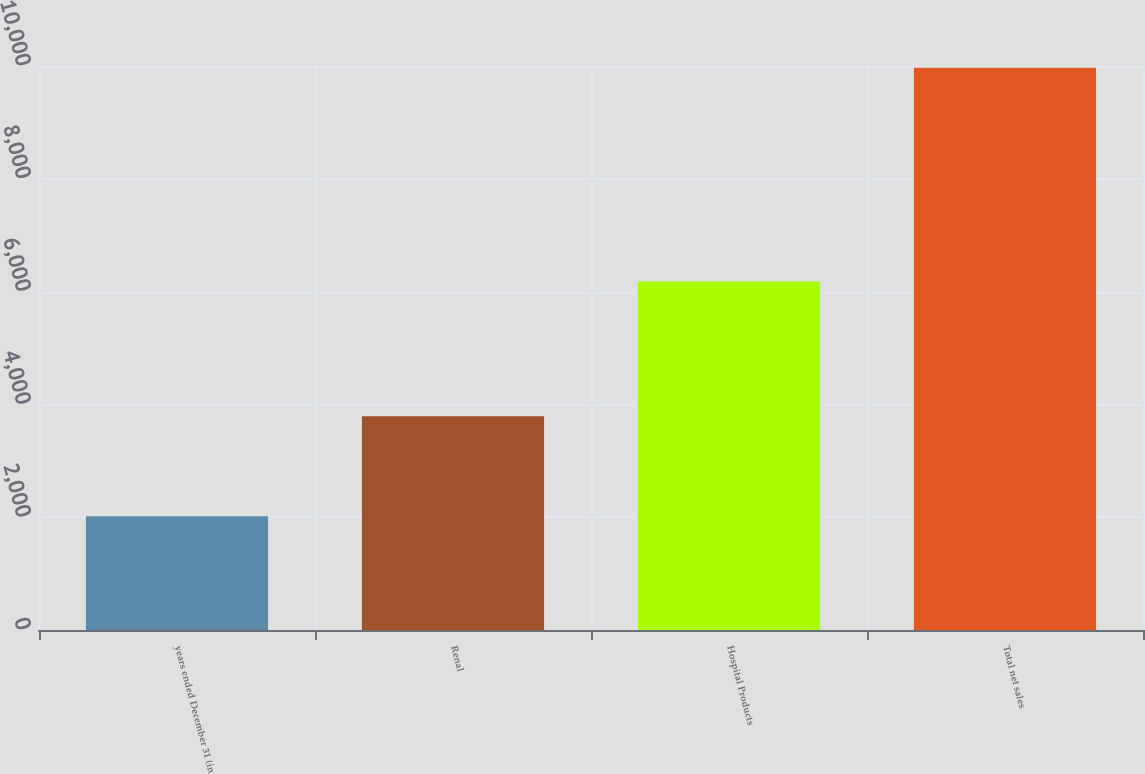Convert chart. <chart><loc_0><loc_0><loc_500><loc_500><bar_chart><fcel>years ended December 31 (in<fcel>Renal<fcel>Hospital Products<fcel>Total net sales<nl><fcel>2015<fcel>3789<fcel>6179<fcel>9968<nl></chart> 